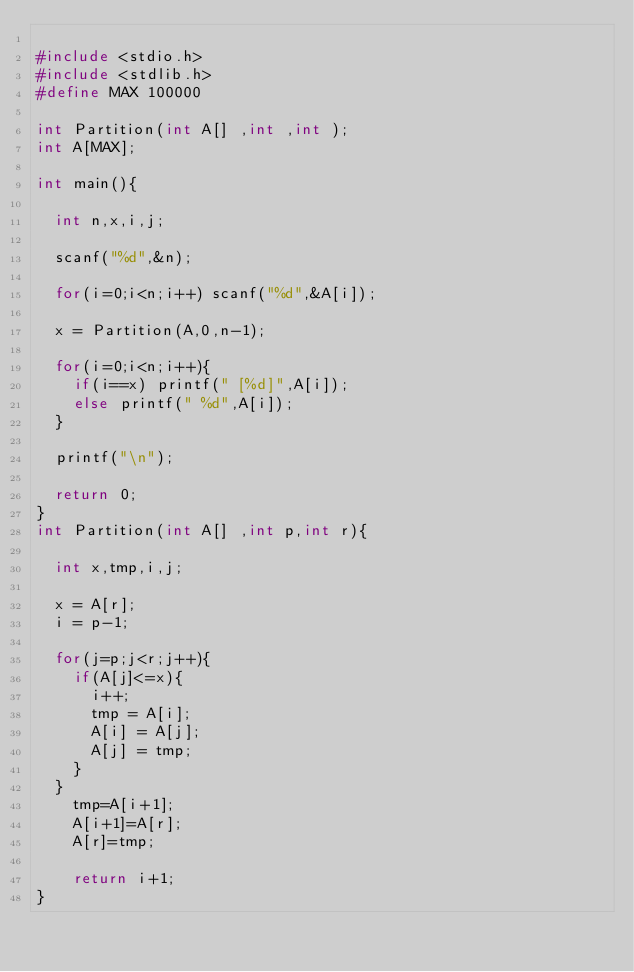<code> <loc_0><loc_0><loc_500><loc_500><_C_>
#include <stdio.h>
#include <stdlib.h>
#define MAX 100000

int Partition(int A[] ,int ,int );
int A[MAX];

int main(){

  int n,x,i,j;

  scanf("%d",&n);

  for(i=0;i<n;i++) scanf("%d",&A[i]);

  x = Partition(A,0,n-1);

  for(i=0;i<n;i++){
    if(i==x) printf(" [%d]",A[i]);
    else printf(" %d",A[i]);
  }
 
  printf("\n");

  return 0;
}
int Partition(int A[] ,int p,int r){

  int x,tmp,i,j;

  x = A[r];
  i = p-1;

  for(j=p;j<r;j++){
    if(A[j]<=x){
      i++;
      tmp = A[i];
      A[i] = A[j];
      A[j] = tmp; 
    }
  }
    tmp=A[i+1];
    A[i+1]=A[r];
    A[r]=tmp;

    return i+1;
}</code> 